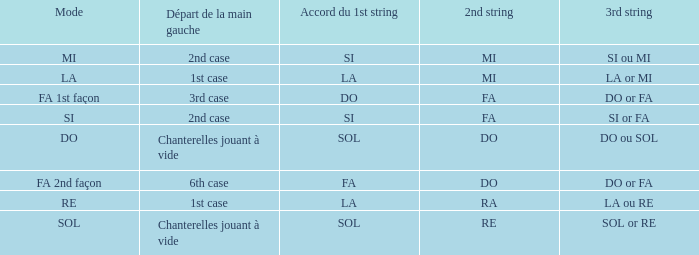What is the Depart de la main gauche of the do Mode? Chanterelles jouant à vide. 